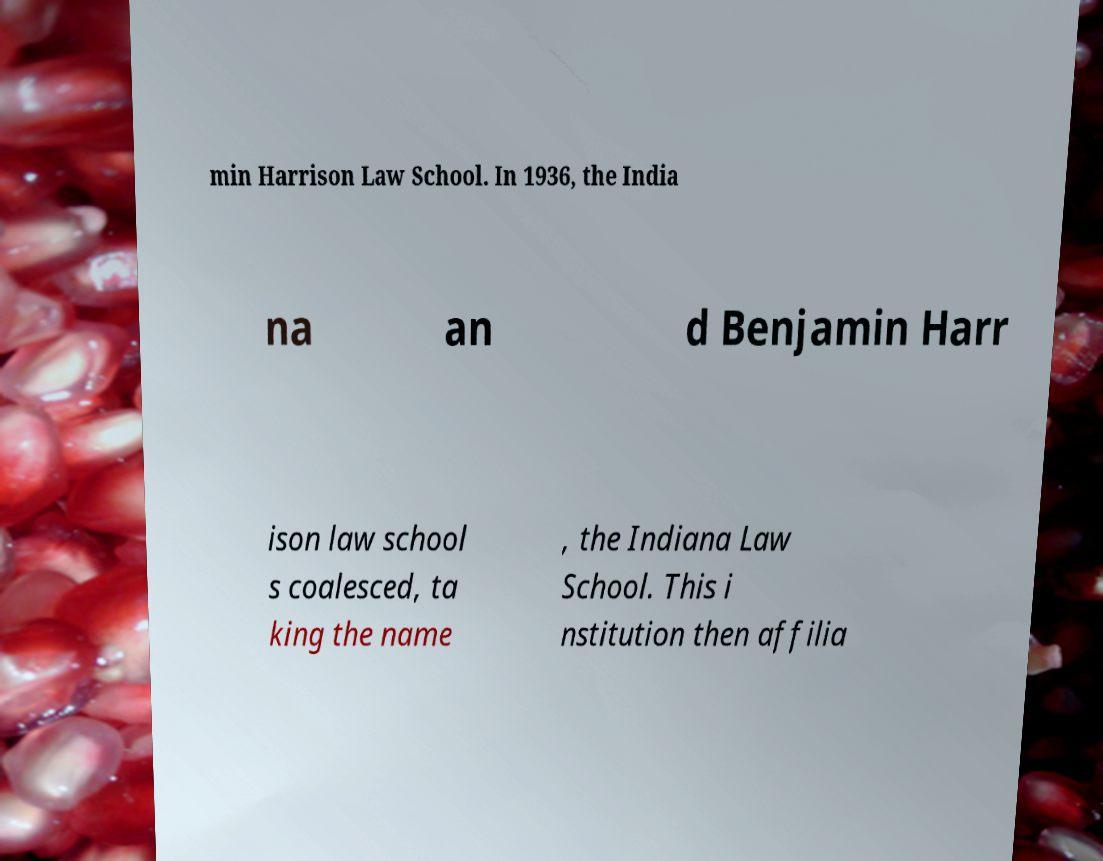Can you read and provide the text displayed in the image?This photo seems to have some interesting text. Can you extract and type it out for me? min Harrison Law School. In 1936, the India na an d Benjamin Harr ison law school s coalesced, ta king the name , the Indiana Law School. This i nstitution then affilia 